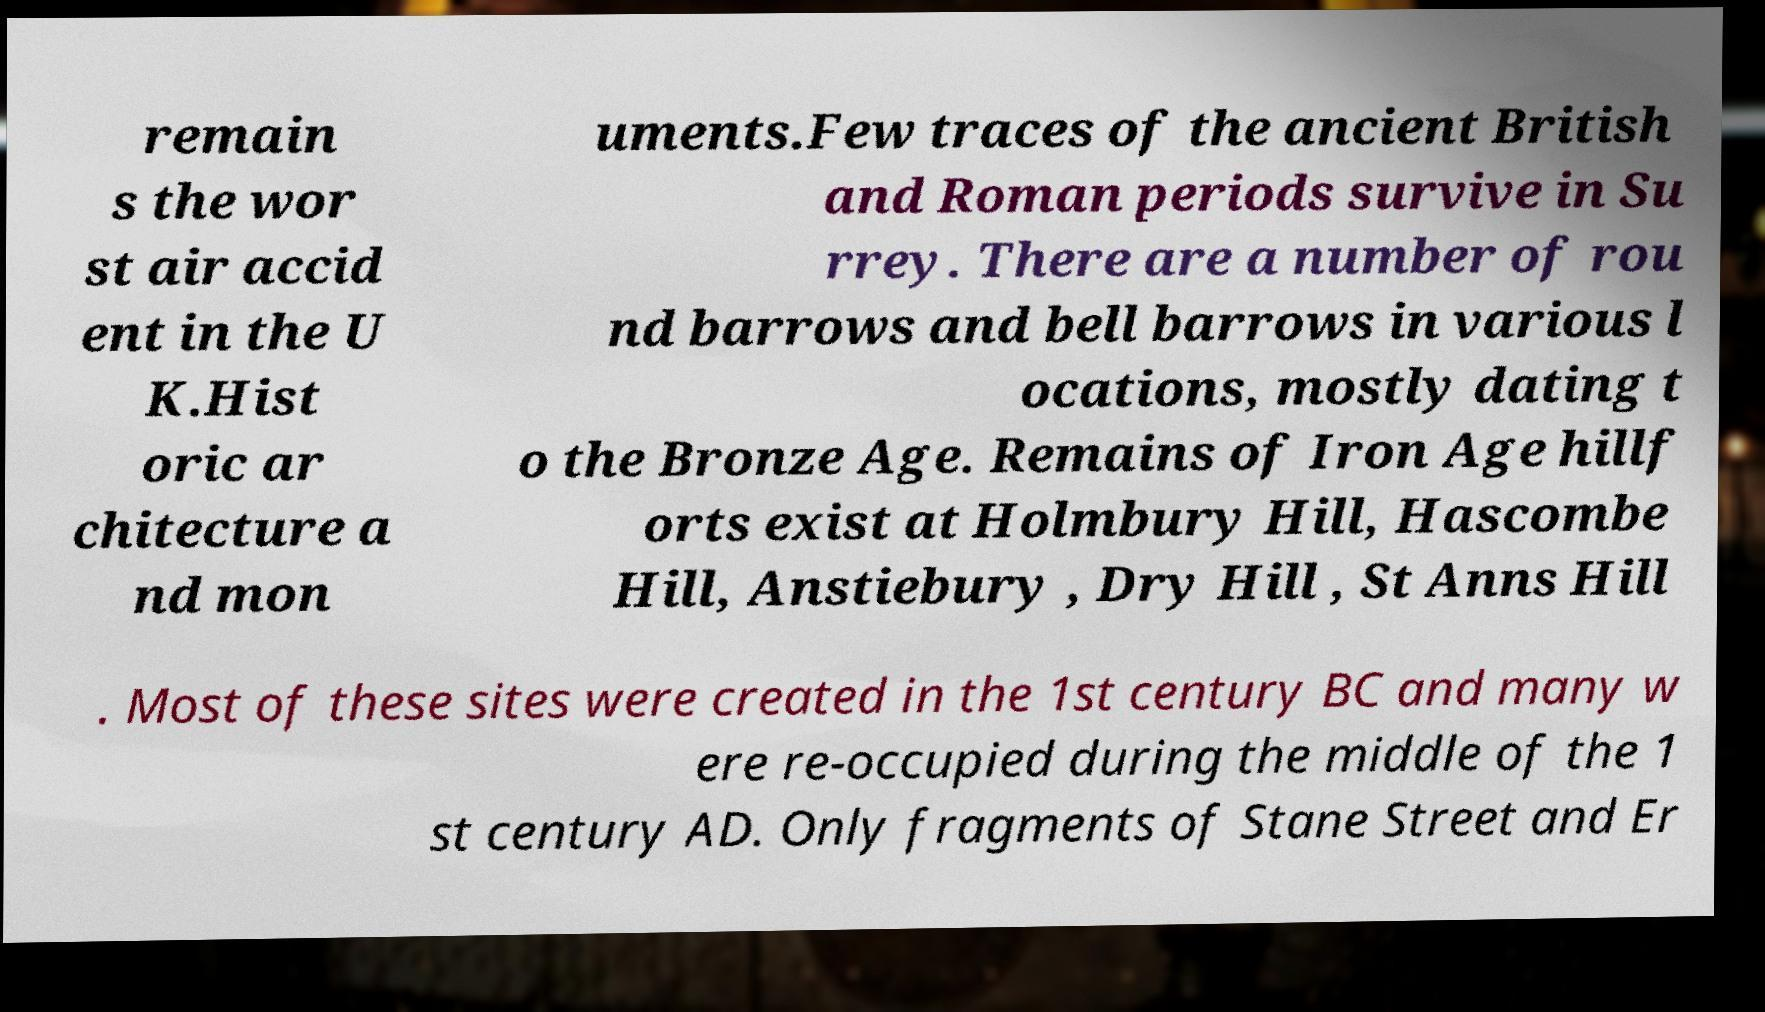Please identify and transcribe the text found in this image. remain s the wor st air accid ent in the U K.Hist oric ar chitecture a nd mon uments.Few traces of the ancient British and Roman periods survive in Su rrey. There are a number of rou nd barrows and bell barrows in various l ocations, mostly dating t o the Bronze Age. Remains of Iron Age hillf orts exist at Holmbury Hill, Hascombe Hill, Anstiebury , Dry Hill , St Anns Hill . Most of these sites were created in the 1st century BC and many w ere re-occupied during the middle of the 1 st century AD. Only fragments of Stane Street and Er 